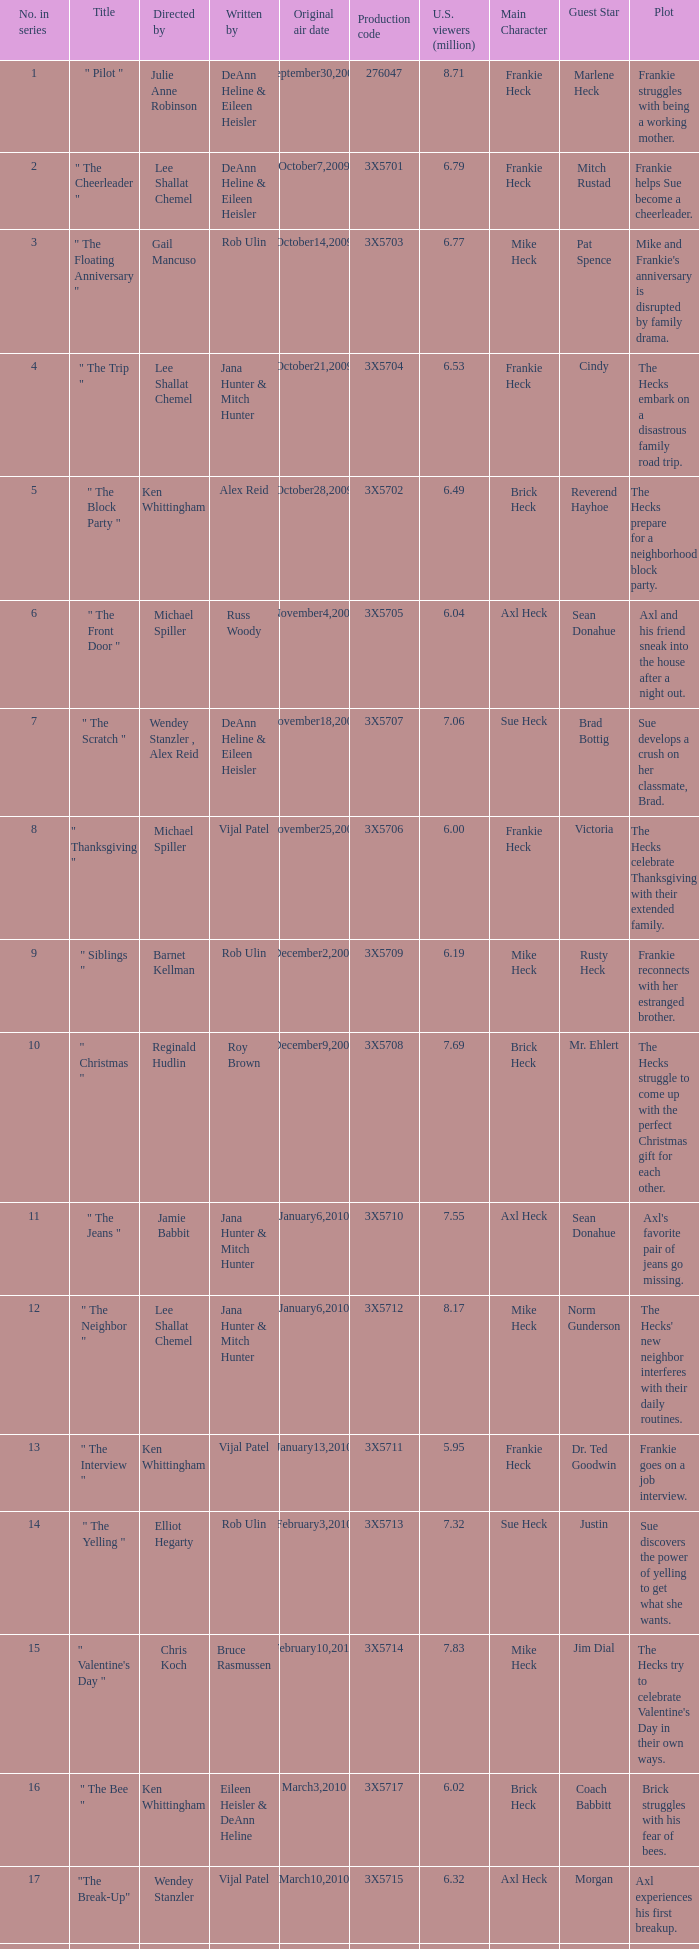Who wrote the episode that got 5.95 million U.S. viewers? Vijal Patel. 